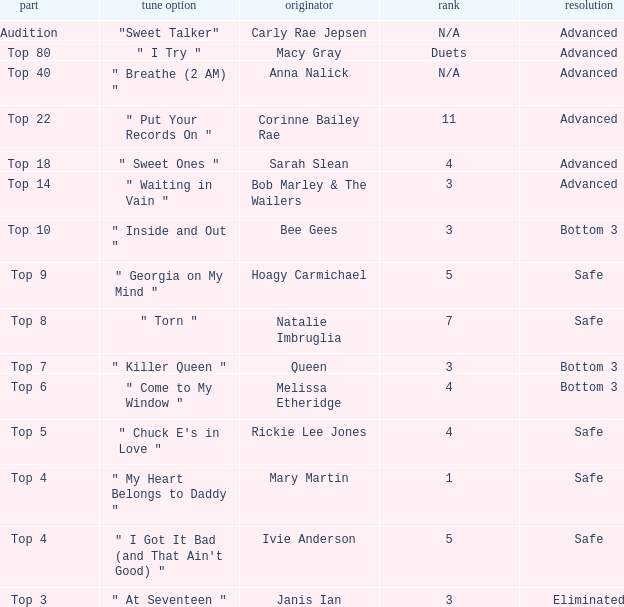What's the total number of songs originally performed by Anna Nalick? 1.0. 